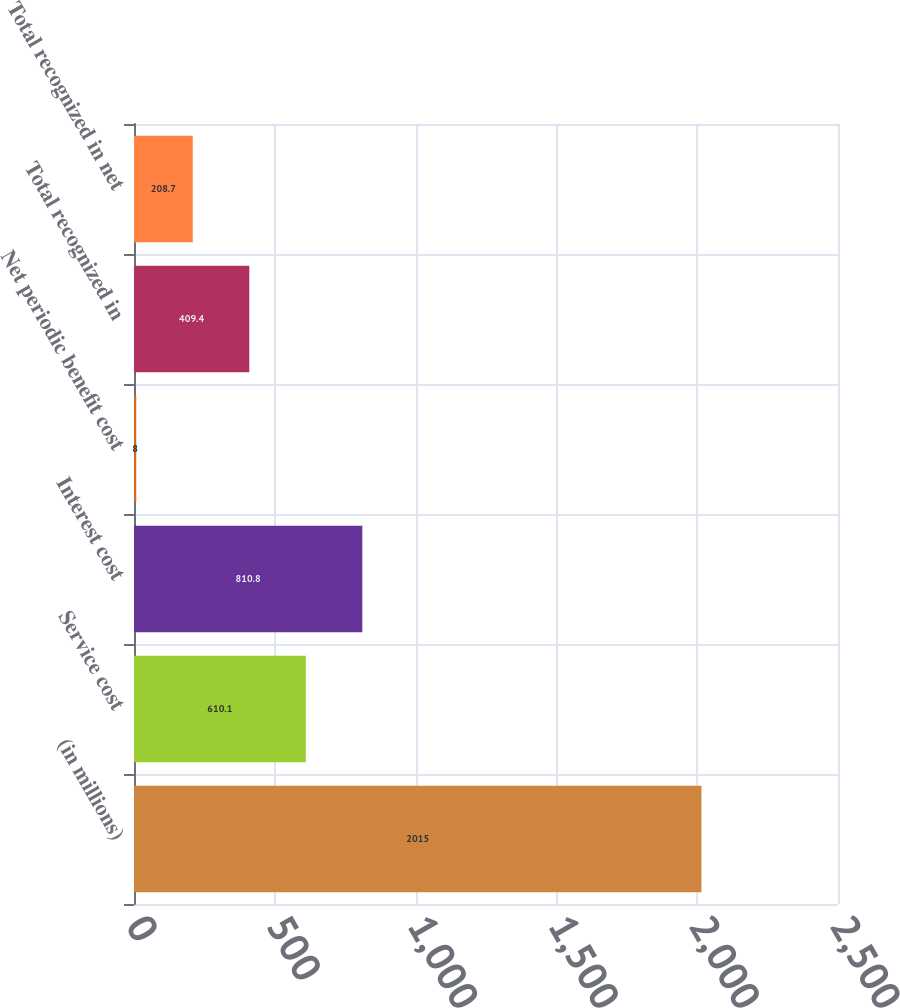Convert chart to OTSL. <chart><loc_0><loc_0><loc_500><loc_500><bar_chart><fcel>(in millions)<fcel>Service cost<fcel>Interest cost<fcel>Net periodic benefit cost<fcel>Total recognized in<fcel>Total recognized in net<nl><fcel>2015<fcel>610.1<fcel>810.8<fcel>8<fcel>409.4<fcel>208.7<nl></chart> 